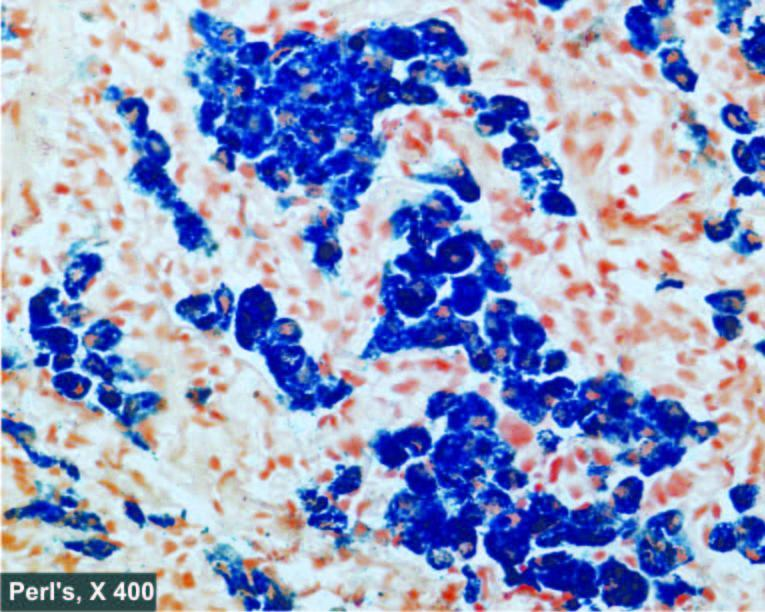what is haemosiderin pigment in the cytoplasm of hepatocytes see as?
Answer the question using a single word or phrase. Prussian blue granules 